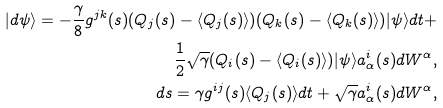Convert formula to latex. <formula><loc_0><loc_0><loc_500><loc_500>| d \psi \rangle = - \frac { \gamma } { 8 } g ^ { j k } ( s ) ( { Q } _ { j } ( s ) - \langle { Q } _ { j } ( s ) \rangle ) ( { Q } _ { k } ( s ) - \langle { Q } _ { k } ( s ) \rangle ) | \psi \rangle d t + \\ \frac { 1 } { 2 } \sqrt { \gamma } ( { Q _ { i } } ( s ) - \langle { Q _ { i } } ( s ) \rangle ) | \psi \rangle a ^ { i } _ { \alpha } ( s ) d W ^ { \alpha } , \\ d s = \gamma g ^ { i j } ( s ) \langle { Q } _ { j } ( s ) \rangle d t + \sqrt { \gamma } a ^ { i } _ { \alpha } ( s ) d W ^ { \alpha } ,</formula> 